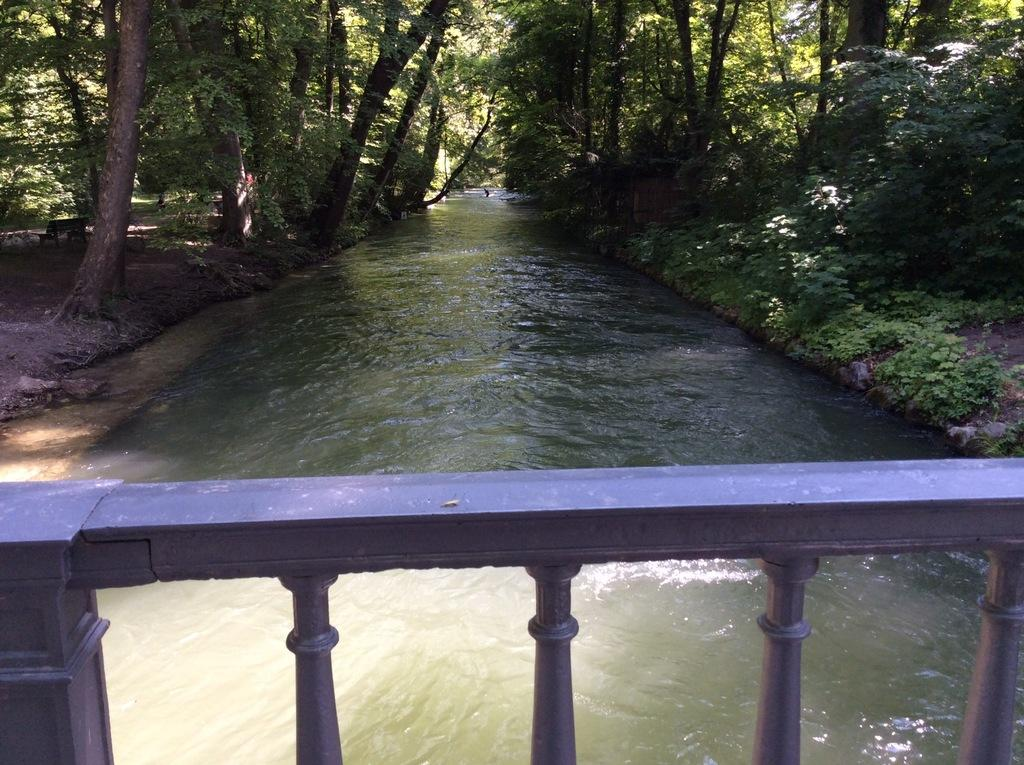What is present in the image that is not solid? There is water visible in the image. What type of vegetation can be seen in the image? There are plants and trees in the image. Where is the bench located in the image? The bench is on the left side of the image. What feature can be seen that might be used for support or safety? There is a railing in the image. What type of whip is being used to tend to the plants in the image? There is no whip present in the image; it features plants, trees, a bench, and a railing. How many houses can be seen in the image? There are no houses present in the image. 